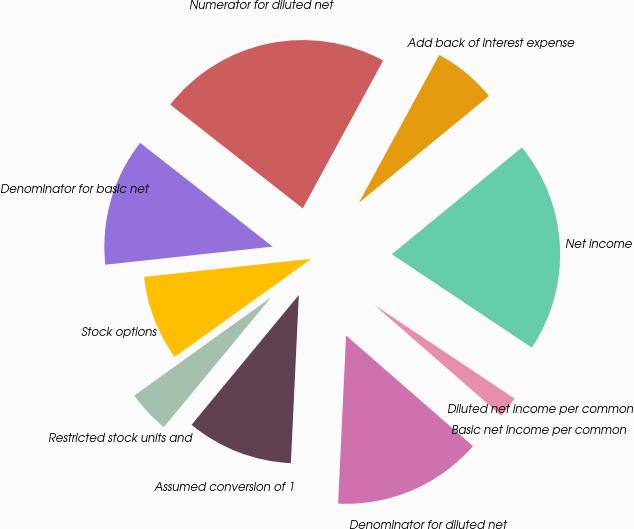Convert chart. <chart><loc_0><loc_0><loc_500><loc_500><pie_chart><fcel>Net income<fcel>Add back of interest expense<fcel>Numerator for diluted net<fcel>Denominator for basic net<fcel>Stock options<fcel>Restricted stock units and<fcel>Assumed conversion of 1<fcel>Denominator for diluted net<fcel>Basic net income per common<fcel>Diluted net income per common<nl><fcel>20.3%<fcel>6.14%<fcel>22.35%<fcel>12.29%<fcel>8.19%<fcel>4.1%<fcel>10.24%<fcel>14.34%<fcel>2.05%<fcel>0.0%<nl></chart> 